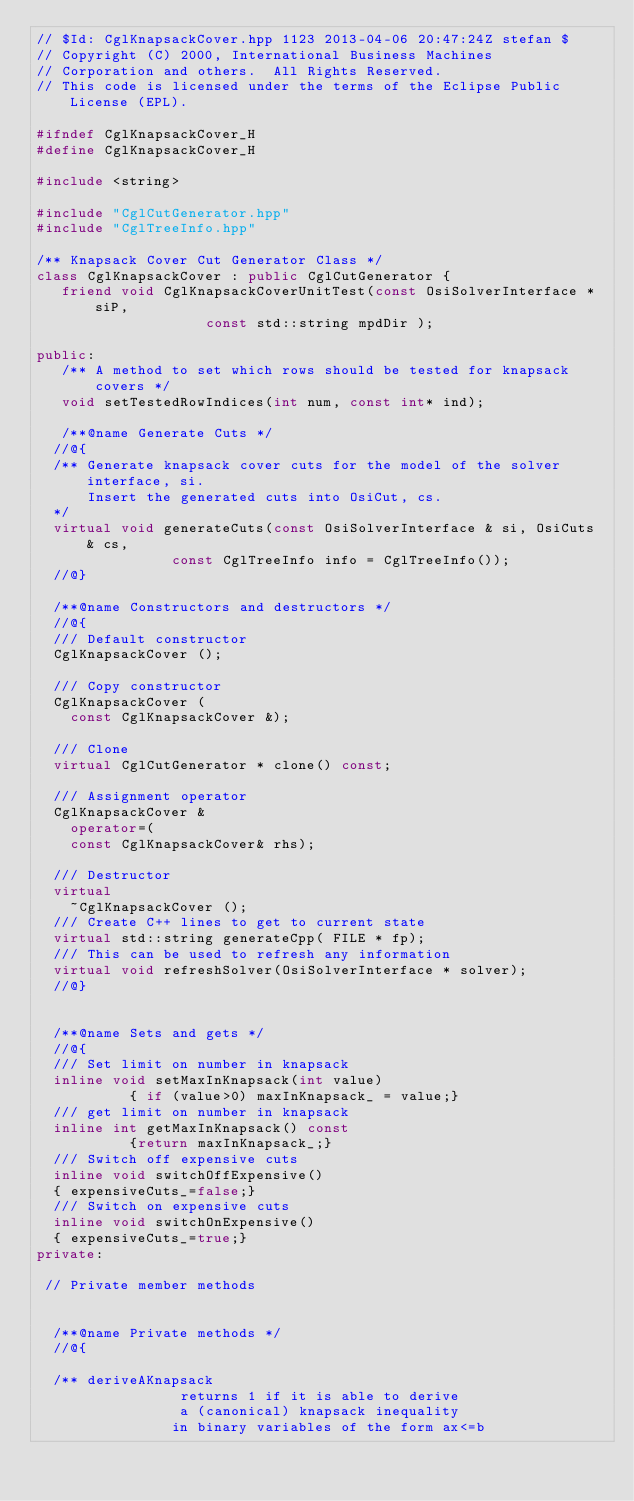Convert code to text. <code><loc_0><loc_0><loc_500><loc_500><_C++_>// $Id: CglKnapsackCover.hpp 1123 2013-04-06 20:47:24Z stefan $
// Copyright (C) 2000, International Business Machines
// Corporation and others.  All Rights Reserved.
// This code is licensed under the terms of the Eclipse Public License (EPL).

#ifndef CglKnapsackCover_H
#define CglKnapsackCover_H

#include <string>

#include "CglCutGenerator.hpp"
#include "CglTreeInfo.hpp"

/** Knapsack Cover Cut Generator Class */
class CglKnapsackCover : public CglCutGenerator {
   friend void CglKnapsackCoverUnitTest(const OsiSolverInterface * siP,
					const std::string mpdDir );

public:
   /** A method to set which rows should be tested for knapsack covers */
   void setTestedRowIndices(int num, const int* ind);

   /**@name Generate Cuts */
  //@{
  /** Generate knapsack cover cuts for the model of the solver interface, si. 
      Insert the generated cuts into OsiCut, cs.
  */
  virtual void generateCuts(const OsiSolverInterface & si, OsiCuts & cs,
			    const CglTreeInfo info = CglTreeInfo());
  //@}

  /**@name Constructors and destructors */
  //@{
  /// Default constructor 
  CglKnapsackCover ();
 
  /// Copy constructor 
  CglKnapsackCover (
    const CglKnapsackCover &);

  /// Clone
  virtual CglCutGenerator * clone() const;

  /// Assignment operator 
  CglKnapsackCover &
    operator=(
    const CglKnapsackCover& rhs);
  
  /// Destructor 
  virtual
    ~CglKnapsackCover ();
  /// Create C++ lines to get to current state
  virtual std::string generateCpp( FILE * fp);
  /// This can be used to refresh any information
  virtual void refreshSolver(OsiSolverInterface * solver);
  //@}


  /**@name Sets and gets */
  //@{
  /// Set limit on number in knapsack
  inline void setMaxInKnapsack(int value)
           { if (value>0) maxInKnapsack_ = value;}
  /// get limit on number in knapsack
  inline int getMaxInKnapsack() const
           {return maxInKnapsack_;}
  /// Switch off expensive cuts
  inline void switchOffExpensive()
  { expensiveCuts_=false;}
  /// Switch on expensive cuts
  inline void switchOnExpensive()
  { expensiveCuts_=true;}
private:
  
 // Private member methods


  /**@name Private methods */
  //@{

  /** deriveAKnapsack 
                 returns 1 if it is able to derive
                 a (canonical) knapsack inequality
                in binary variables of the form ax<=b </code> 